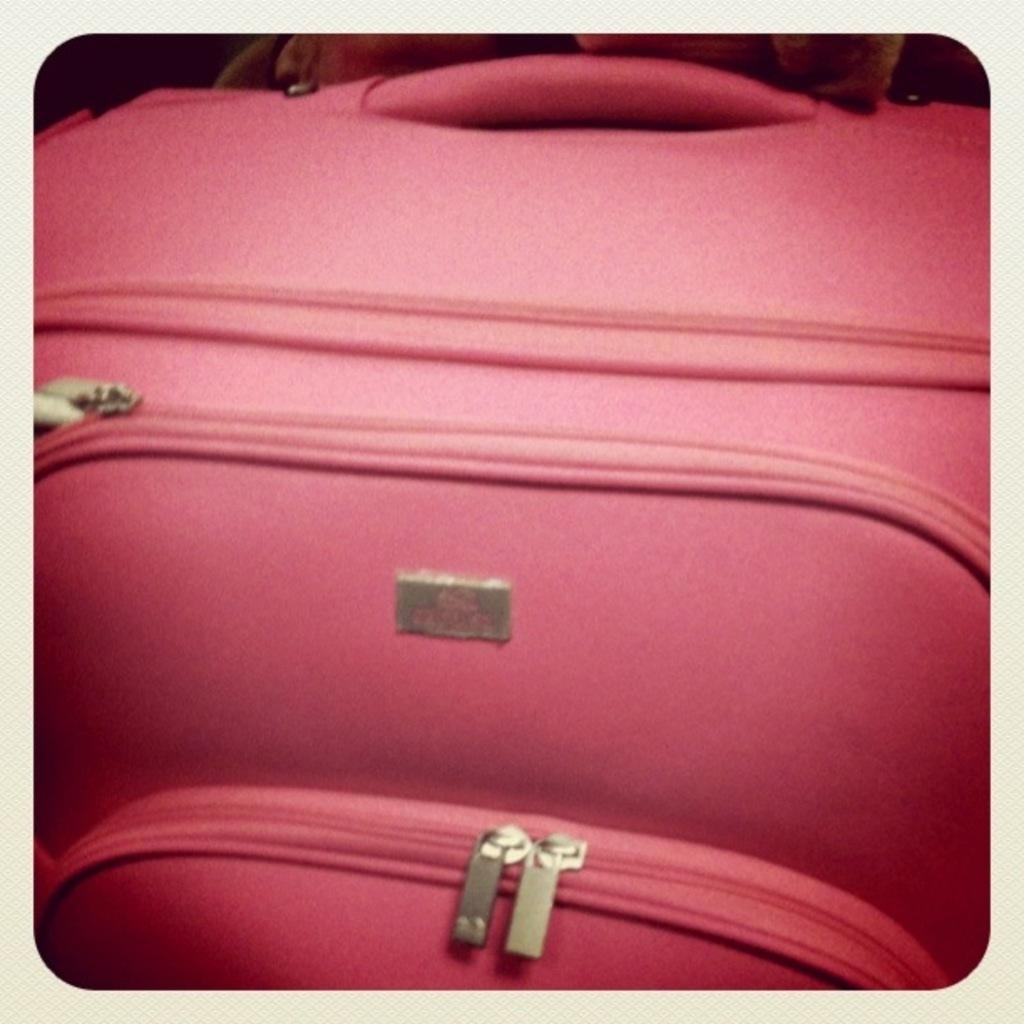What object can be seen in the image? There is a suitcase in the image. What is the color of the suitcase? The suitcase is pink in color. Is there a light bulb (bulb) attached to the suitcase in the image? No, there is no light bulb (bulb) attached to the suitcase in the image. Are there any mittens (mitten) visible in the image? No, there are no mittens (mitten) visible in the image. 